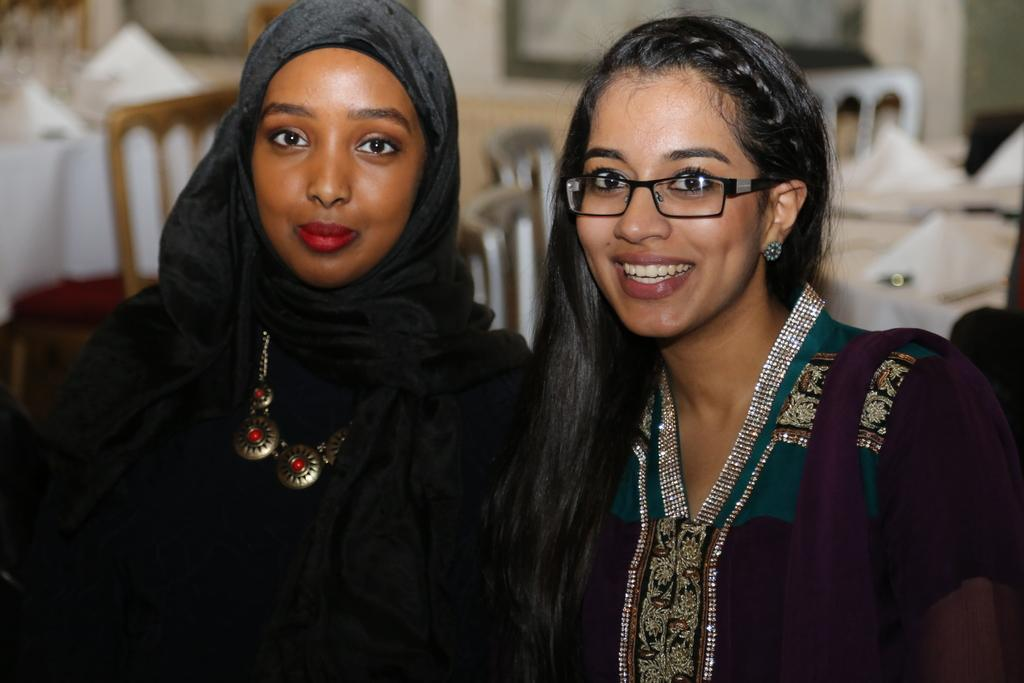How many girls are in the image? There are two girls in the image. Where are the girls positioned in the image? The girls are standing in the front. What expression do the girls have in the image? The girls are smiling in the image. What are the girls doing in the image? The girls are giving a pose to the camera. What can be seen in the background of the image? Dining tables and chairs are visible in the background of the image. What type of spot is the girls working on in the image? There is no spot or work being done in the image; the girls are posing for a photo and smiling. 